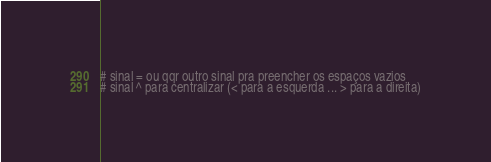<code> <loc_0><loc_0><loc_500><loc_500><_Python_># sinal = ou qqr outro sinal pra preencher os espaços vazios
# sinal ^ para centralizar (< para a esquerda ... > para a direita)

</code> 